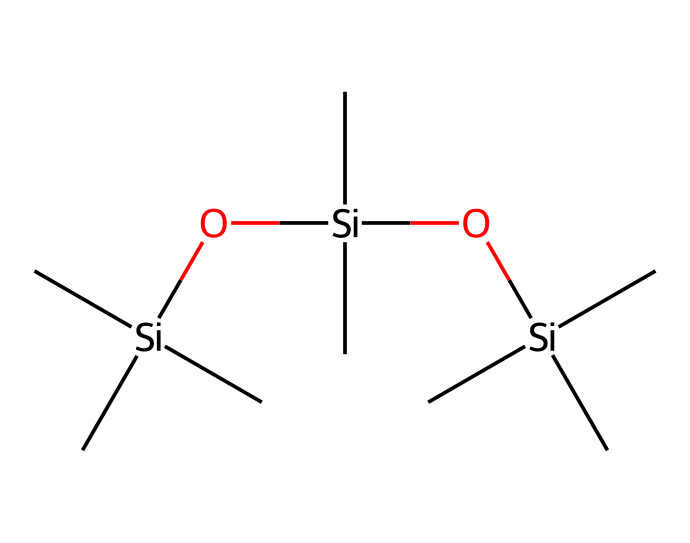What is the primary functional group in this chemical? The chemical structure contains silicon atoms bonded with oxygen, primarily forming siloxane linkages. These linkages indicate the presence of a silanol functional group.
Answer: silanol How many silicon atoms are present in the structure? By analyzing the SMILES representation, we see three instances of the silicon atom 'Si.' Each 'Si' in the SMILES corresponds to one silicon atom, totaling to three.
Answer: three What type of bonding is predominant in this lubricant? The predominant bonding in this compound can be identified by the silicon-oxygen bonds typical in polysiloxanes, which creates a flexible and lubricating structure suitable for anti-friction applications.
Answer: siloxane bonds What is the reason for using this compound in gaming chair mechanisms? The structure's siloxane nature provides low friction properties, enabling smooth movement and reducing wear in mechanical components, which is crucial for gaming chair mechanisms where interaction is frequent.
Answer: low friction properties How many total carbon atoms are in this compound? The structure indicated by the SMILES shows that each 'C' represents a carbon atom. Counting the 'C's, we find a total of 12 carbon atoms in the formula.
Answer: twelve 